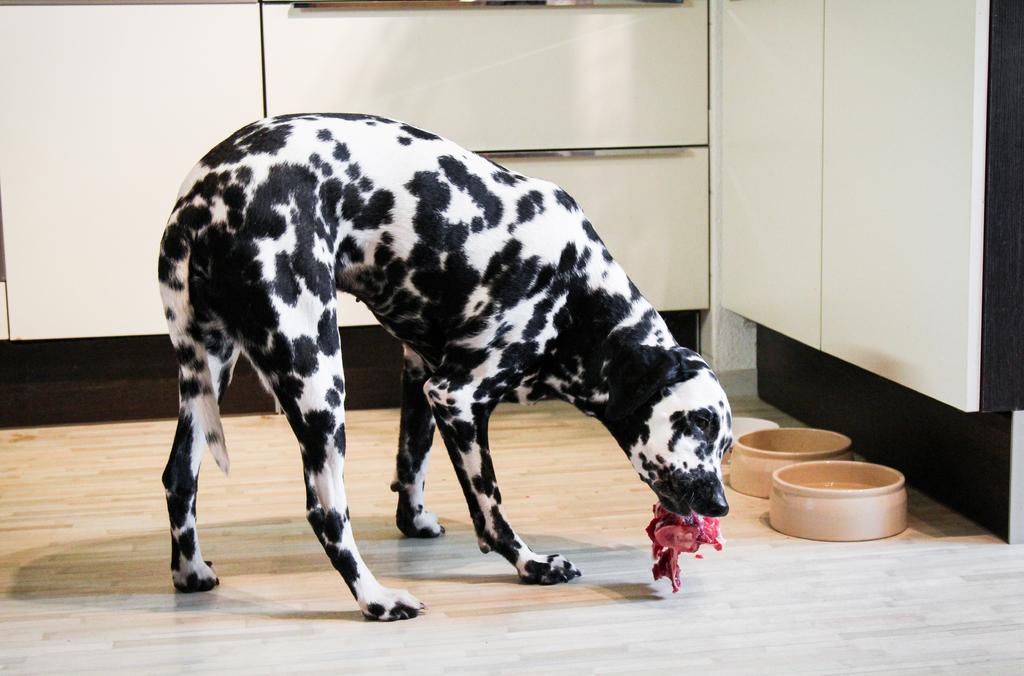In one or two sentences, can you explain what this image depicts? In the image we can see there is a dog standing and there is a meat piece in his mouth. There are two bowls kept on the floor. 